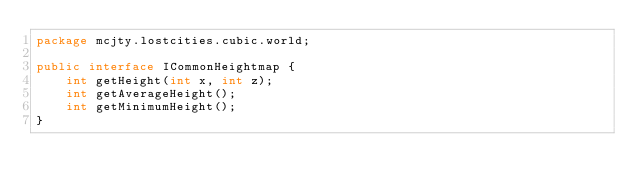Convert code to text. <code><loc_0><loc_0><loc_500><loc_500><_Java_>package mcjty.lostcities.cubic.world;

public interface ICommonHeightmap {
    int getHeight(int x, int z);
    int getAverageHeight();
    int getMinimumHeight();
}
</code> 